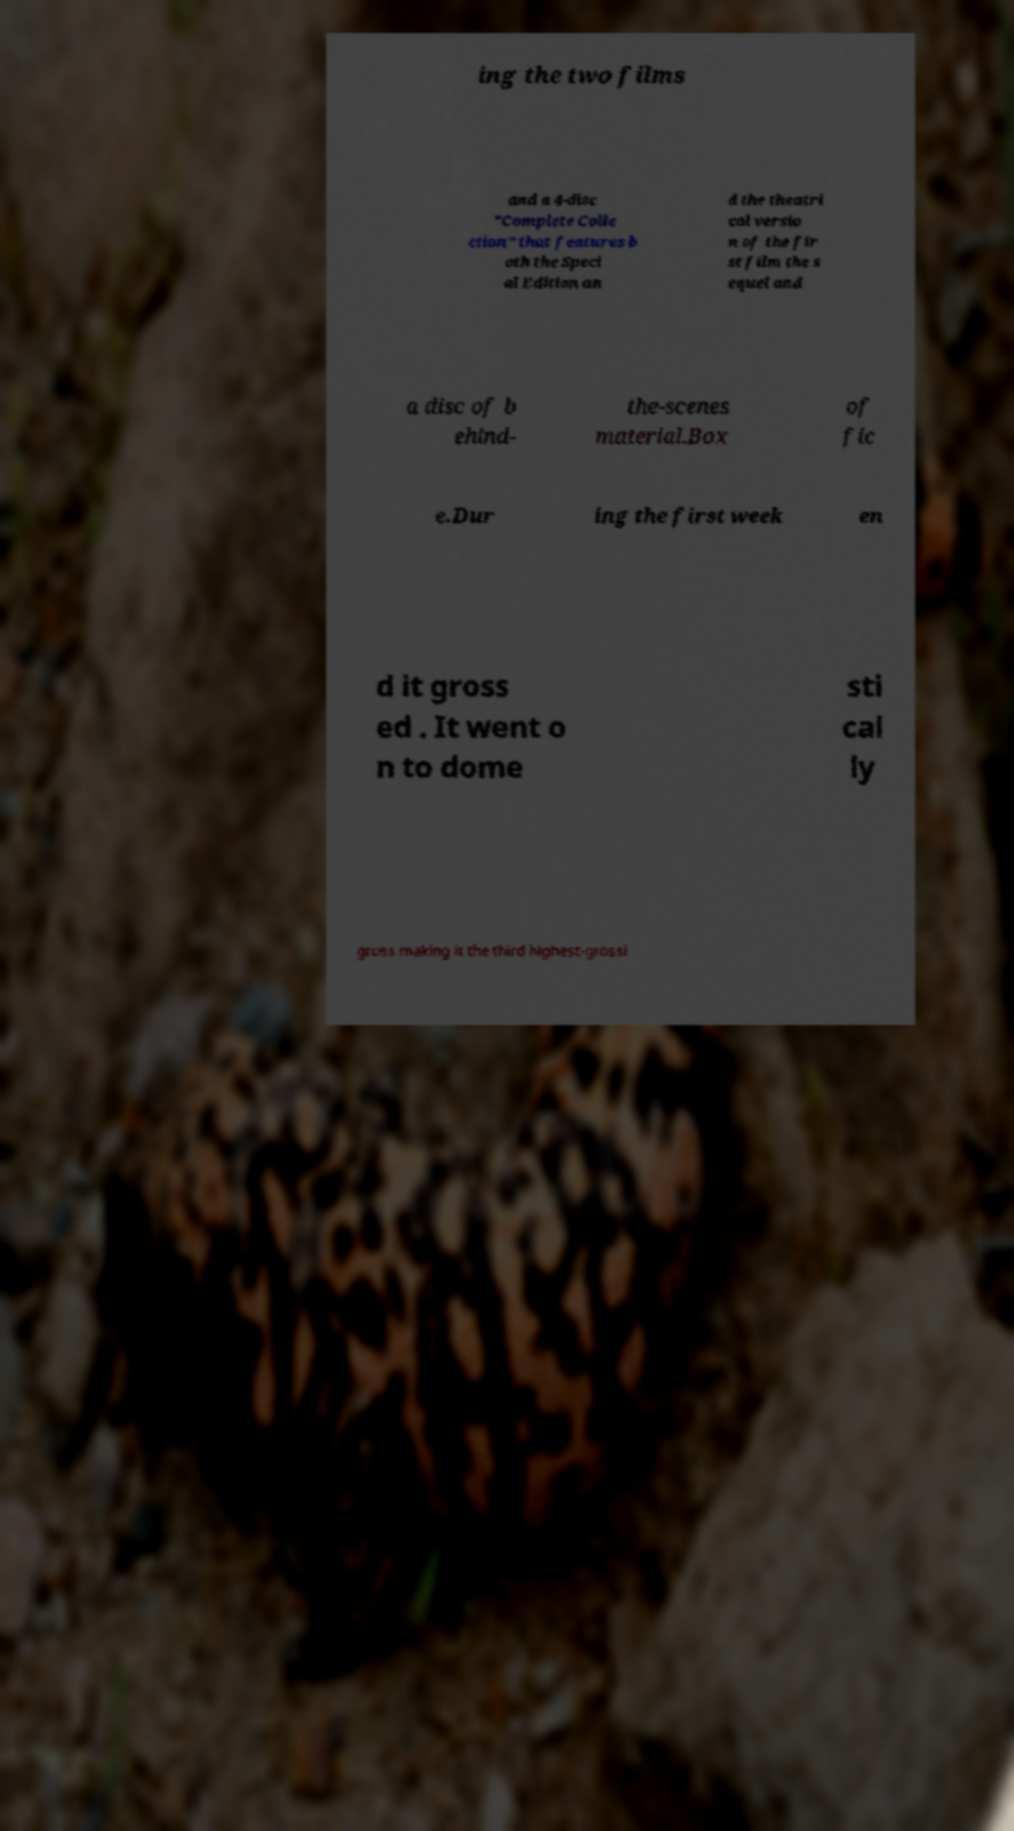Could you assist in decoding the text presented in this image and type it out clearly? ing the two films and a 4-disc "Complete Colle ction" that features b oth the Speci al Edition an d the theatri cal versio n of the fir st film the s equel and a disc of b ehind- the-scenes material.Box of fic e.Dur ing the first week en d it gross ed . It went o n to dome sti cal ly gross making it the third highest-grossi 